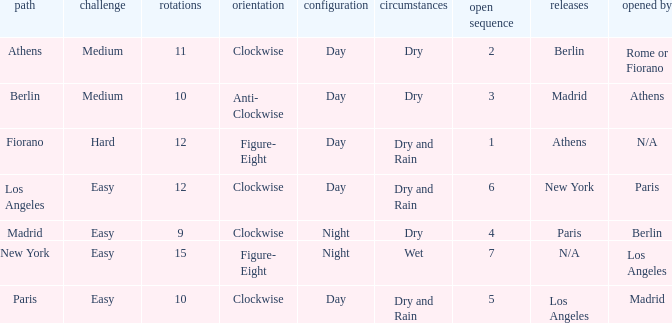I'm looking to parse the entire table for insights. Could you assist me with that? {'header': ['path', 'challenge', 'rotations', 'orientation', 'configuration', 'circumstances', 'open sequence', 'releases', 'opened by'], 'rows': [['Athens', 'Medium', '11', 'Clockwise', 'Day', 'Dry', '2', 'Berlin', 'Rome or Fiorano'], ['Berlin', 'Medium', '10', 'Anti- Clockwise', 'Day', 'Dry', '3', 'Madrid', 'Athens'], ['Fiorano', 'Hard', '12', 'Figure- Eight', 'Day', 'Dry and Rain', '1', 'Athens', 'N/A'], ['Los Angeles', 'Easy', '12', 'Clockwise', 'Day', 'Dry and Rain', '6', 'New York', 'Paris'], ['Madrid', 'Easy', '9', 'Clockwise', 'Night', 'Dry', '4', 'Paris', 'Berlin'], ['New York', 'Easy', '15', 'Figure- Eight', 'Night', 'Wet', '7', 'N/A', 'Los Angeles'], ['Paris', 'Easy', '10', 'Clockwise', 'Day', 'Dry and Rain', '5', 'Los Angeles', 'Madrid']]} How many instances is the unlocked n/a? 1.0. 